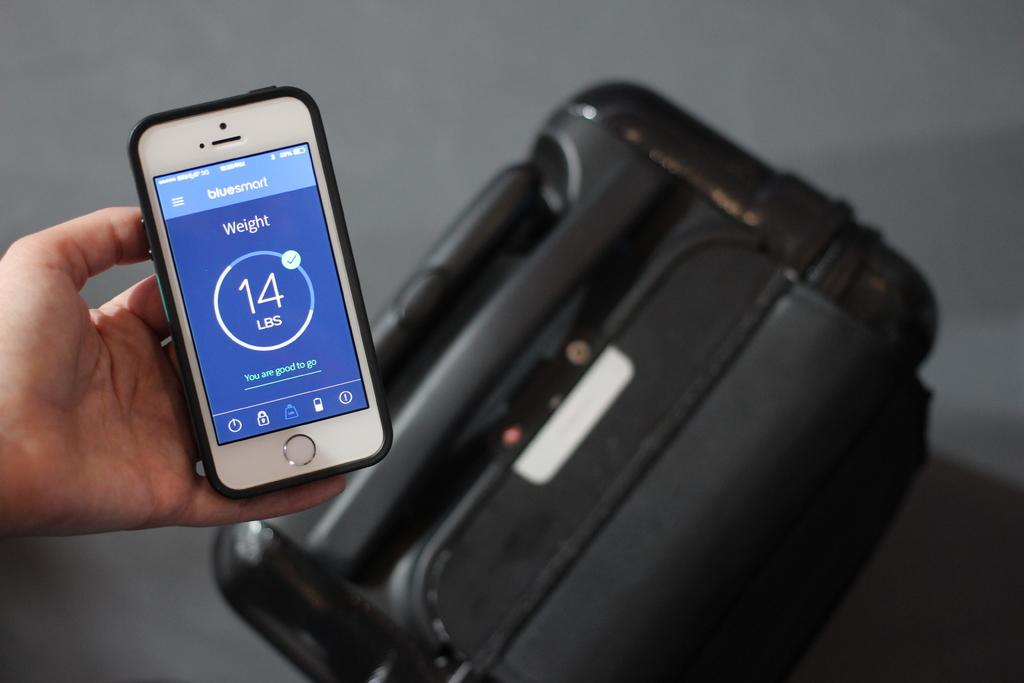<image>
Render a clear and concise summary of the photo. Iphone that shows a bluesmart app with a weight total on the screen. 